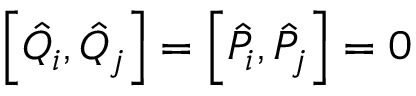Convert formula to latex. <formula><loc_0><loc_0><loc_500><loc_500>\left [ \hat { Q } _ { i } , \hat { Q } _ { j } \right ] = \left [ \hat { P } _ { i } , \hat { P } _ { j } \right ] = 0</formula> 